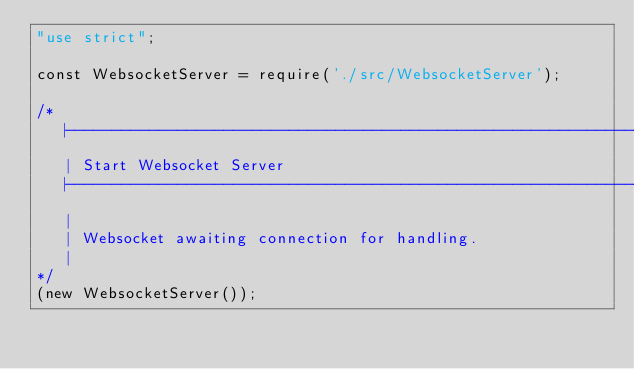<code> <loc_0><loc_0><loc_500><loc_500><_JavaScript_>"use strict";

const WebsocketServer = require('./src/WebsocketServer');

/*
   |--------------------------------------------------------------------------
   | Start Websocket Server
   |--------------------------------------------------------------------------
   |
   | Websocket awaiting connection for handling.
   |
*/
(new WebsocketServer());</code> 